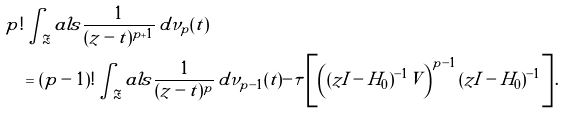<formula> <loc_0><loc_0><loc_500><loc_500>& p ! \int _ { \Re } a l s \frac { 1 } { ( z - t ) ^ { p + 1 } } \, d \nu _ { p } ( t ) \\ & \quad = ( p - 1 ) ! \int _ { \Re } a l s \frac { 1 } { ( z - t ) ^ { p } } \, d \nu _ { p - 1 } ( t ) - \tau \left [ \left ( ( z I - H _ { 0 } ) ^ { - 1 } V \right ) ^ { p - 1 } ( z I - H _ { 0 } ) ^ { - 1 } \right ] .</formula> 